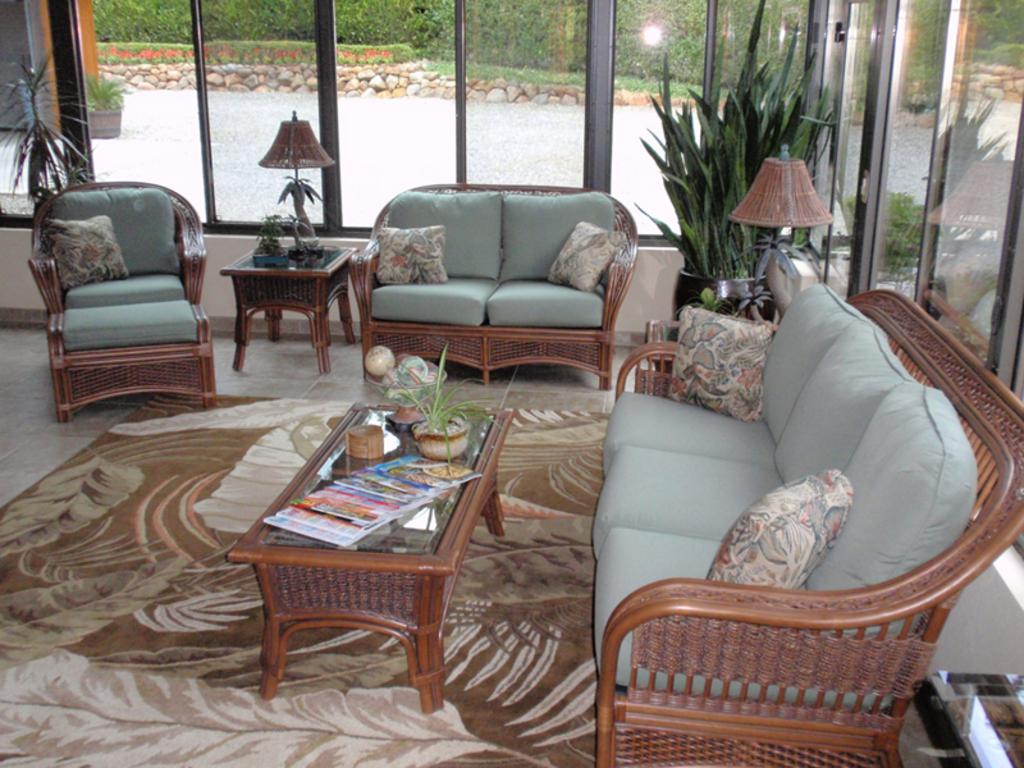What type of furniture is present in the image? There is a sofa and chairs with cushions in the image. What else can be seen in the image besides furniture? There are plants, lamps, and books on a table in the image. What type of store is visible in the image? There is no store present in the image. Can you tell me which camera was used to take the picture? The information provided does not include details about the camera used to take the picture. 